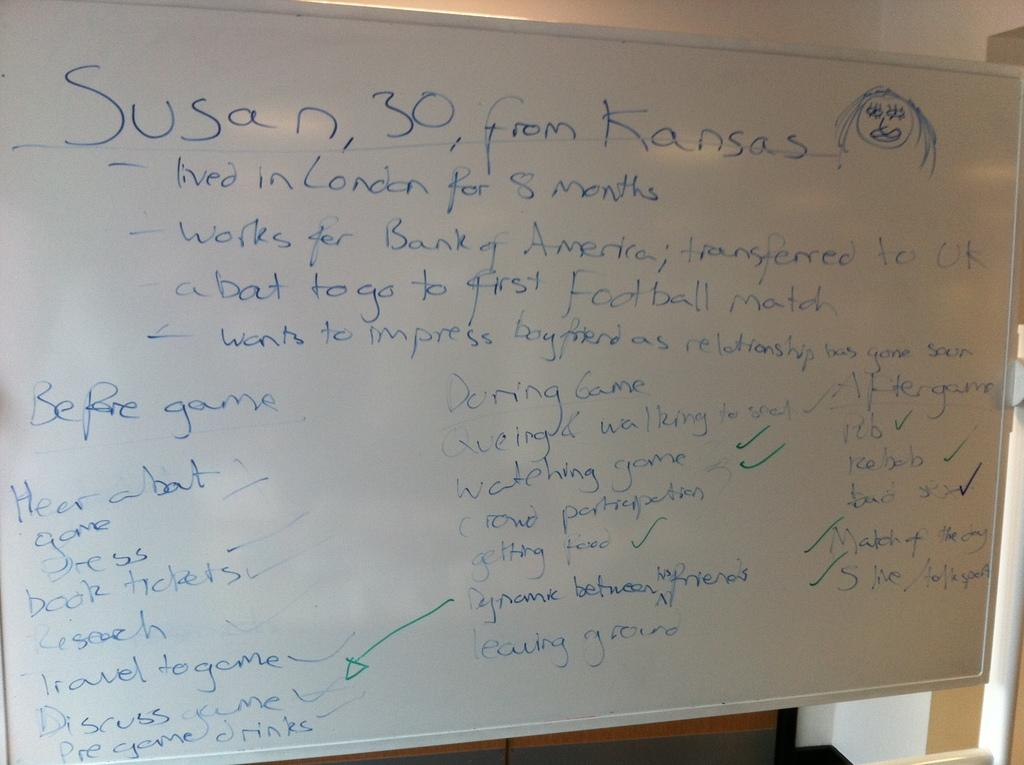Provide a one-sentence caption for the provided image. a write board with a lot of writing on it with the top saying susan,30, from kansas. 